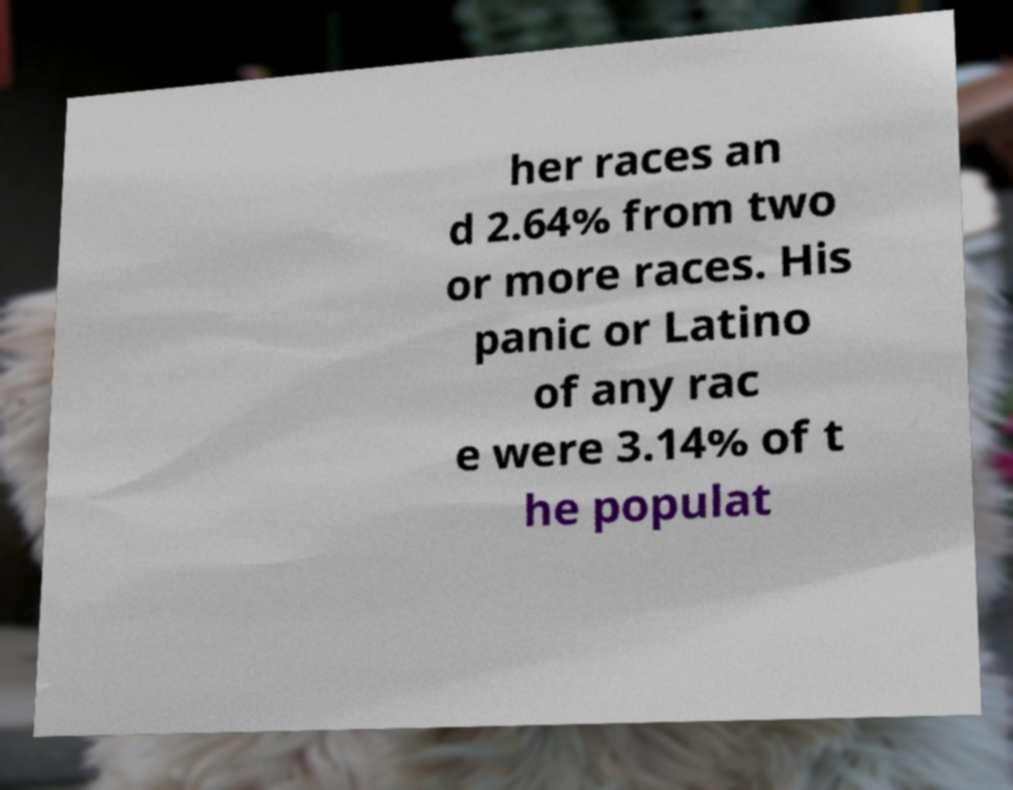I need the written content from this picture converted into text. Can you do that? her races an d 2.64% from two or more races. His panic or Latino of any rac e were 3.14% of t he populat 